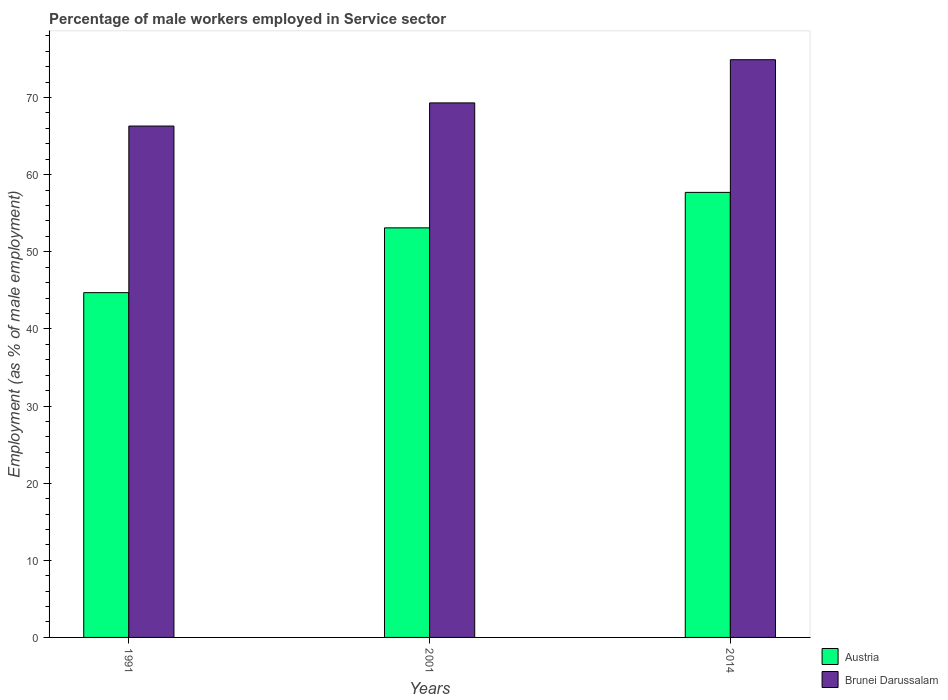How many groups of bars are there?
Offer a terse response. 3. Are the number of bars per tick equal to the number of legend labels?
Give a very brief answer. Yes. Are the number of bars on each tick of the X-axis equal?
Keep it short and to the point. Yes. How many bars are there on the 2nd tick from the left?
Offer a terse response. 2. How many bars are there on the 1st tick from the right?
Give a very brief answer. 2. What is the percentage of male workers employed in Service sector in Brunei Darussalam in 2014?
Provide a short and direct response. 74.9. Across all years, what is the maximum percentage of male workers employed in Service sector in Brunei Darussalam?
Offer a terse response. 74.9. Across all years, what is the minimum percentage of male workers employed in Service sector in Brunei Darussalam?
Your answer should be very brief. 66.3. In which year was the percentage of male workers employed in Service sector in Austria maximum?
Provide a short and direct response. 2014. What is the total percentage of male workers employed in Service sector in Brunei Darussalam in the graph?
Provide a short and direct response. 210.5. What is the difference between the percentage of male workers employed in Service sector in Austria in 2001 and that in 2014?
Offer a very short reply. -4.6. What is the difference between the percentage of male workers employed in Service sector in Brunei Darussalam in 2014 and the percentage of male workers employed in Service sector in Austria in 2001?
Your answer should be compact. 21.8. What is the average percentage of male workers employed in Service sector in Brunei Darussalam per year?
Offer a terse response. 70.17. In the year 2014, what is the difference between the percentage of male workers employed in Service sector in Brunei Darussalam and percentage of male workers employed in Service sector in Austria?
Keep it short and to the point. 17.2. In how many years, is the percentage of male workers employed in Service sector in Austria greater than 56 %?
Your answer should be very brief. 1. What is the ratio of the percentage of male workers employed in Service sector in Austria in 1991 to that in 2014?
Your response must be concise. 0.77. What is the difference between the highest and the second highest percentage of male workers employed in Service sector in Austria?
Offer a very short reply. 4.6. What is the difference between the highest and the lowest percentage of male workers employed in Service sector in Austria?
Offer a very short reply. 13. Is the sum of the percentage of male workers employed in Service sector in Austria in 1991 and 2014 greater than the maximum percentage of male workers employed in Service sector in Brunei Darussalam across all years?
Give a very brief answer. Yes. What does the 2nd bar from the left in 2014 represents?
Offer a terse response. Brunei Darussalam. How many bars are there?
Give a very brief answer. 6. How many years are there in the graph?
Your answer should be very brief. 3. What is the difference between two consecutive major ticks on the Y-axis?
Your response must be concise. 10. Does the graph contain any zero values?
Your answer should be compact. No. Does the graph contain grids?
Offer a very short reply. No. How many legend labels are there?
Your response must be concise. 2. How are the legend labels stacked?
Provide a succinct answer. Vertical. What is the title of the graph?
Give a very brief answer. Percentage of male workers employed in Service sector. What is the label or title of the Y-axis?
Your response must be concise. Employment (as % of male employment). What is the Employment (as % of male employment) in Austria in 1991?
Keep it short and to the point. 44.7. What is the Employment (as % of male employment) of Brunei Darussalam in 1991?
Offer a very short reply. 66.3. What is the Employment (as % of male employment) of Austria in 2001?
Keep it short and to the point. 53.1. What is the Employment (as % of male employment) of Brunei Darussalam in 2001?
Make the answer very short. 69.3. What is the Employment (as % of male employment) in Austria in 2014?
Keep it short and to the point. 57.7. What is the Employment (as % of male employment) of Brunei Darussalam in 2014?
Provide a short and direct response. 74.9. Across all years, what is the maximum Employment (as % of male employment) of Austria?
Your response must be concise. 57.7. Across all years, what is the maximum Employment (as % of male employment) of Brunei Darussalam?
Provide a succinct answer. 74.9. Across all years, what is the minimum Employment (as % of male employment) of Austria?
Offer a terse response. 44.7. Across all years, what is the minimum Employment (as % of male employment) in Brunei Darussalam?
Ensure brevity in your answer.  66.3. What is the total Employment (as % of male employment) in Austria in the graph?
Make the answer very short. 155.5. What is the total Employment (as % of male employment) in Brunei Darussalam in the graph?
Offer a very short reply. 210.5. What is the difference between the Employment (as % of male employment) of Brunei Darussalam in 1991 and that in 2001?
Offer a very short reply. -3. What is the difference between the Employment (as % of male employment) in Brunei Darussalam in 1991 and that in 2014?
Offer a terse response. -8.6. What is the difference between the Employment (as % of male employment) in Austria in 2001 and that in 2014?
Ensure brevity in your answer.  -4.6. What is the difference between the Employment (as % of male employment) of Brunei Darussalam in 2001 and that in 2014?
Your response must be concise. -5.6. What is the difference between the Employment (as % of male employment) of Austria in 1991 and the Employment (as % of male employment) of Brunei Darussalam in 2001?
Provide a succinct answer. -24.6. What is the difference between the Employment (as % of male employment) in Austria in 1991 and the Employment (as % of male employment) in Brunei Darussalam in 2014?
Your answer should be compact. -30.2. What is the difference between the Employment (as % of male employment) of Austria in 2001 and the Employment (as % of male employment) of Brunei Darussalam in 2014?
Your answer should be compact. -21.8. What is the average Employment (as % of male employment) of Austria per year?
Your response must be concise. 51.83. What is the average Employment (as % of male employment) of Brunei Darussalam per year?
Give a very brief answer. 70.17. In the year 1991, what is the difference between the Employment (as % of male employment) in Austria and Employment (as % of male employment) in Brunei Darussalam?
Give a very brief answer. -21.6. In the year 2001, what is the difference between the Employment (as % of male employment) of Austria and Employment (as % of male employment) of Brunei Darussalam?
Your response must be concise. -16.2. In the year 2014, what is the difference between the Employment (as % of male employment) of Austria and Employment (as % of male employment) of Brunei Darussalam?
Offer a very short reply. -17.2. What is the ratio of the Employment (as % of male employment) of Austria in 1991 to that in 2001?
Offer a terse response. 0.84. What is the ratio of the Employment (as % of male employment) in Brunei Darussalam in 1991 to that in 2001?
Your answer should be compact. 0.96. What is the ratio of the Employment (as % of male employment) in Austria in 1991 to that in 2014?
Provide a succinct answer. 0.77. What is the ratio of the Employment (as % of male employment) of Brunei Darussalam in 1991 to that in 2014?
Ensure brevity in your answer.  0.89. What is the ratio of the Employment (as % of male employment) of Austria in 2001 to that in 2014?
Provide a succinct answer. 0.92. What is the ratio of the Employment (as % of male employment) of Brunei Darussalam in 2001 to that in 2014?
Your response must be concise. 0.93. What is the difference between the highest and the second highest Employment (as % of male employment) in Brunei Darussalam?
Offer a very short reply. 5.6. What is the difference between the highest and the lowest Employment (as % of male employment) of Austria?
Offer a very short reply. 13. What is the difference between the highest and the lowest Employment (as % of male employment) in Brunei Darussalam?
Your answer should be very brief. 8.6. 